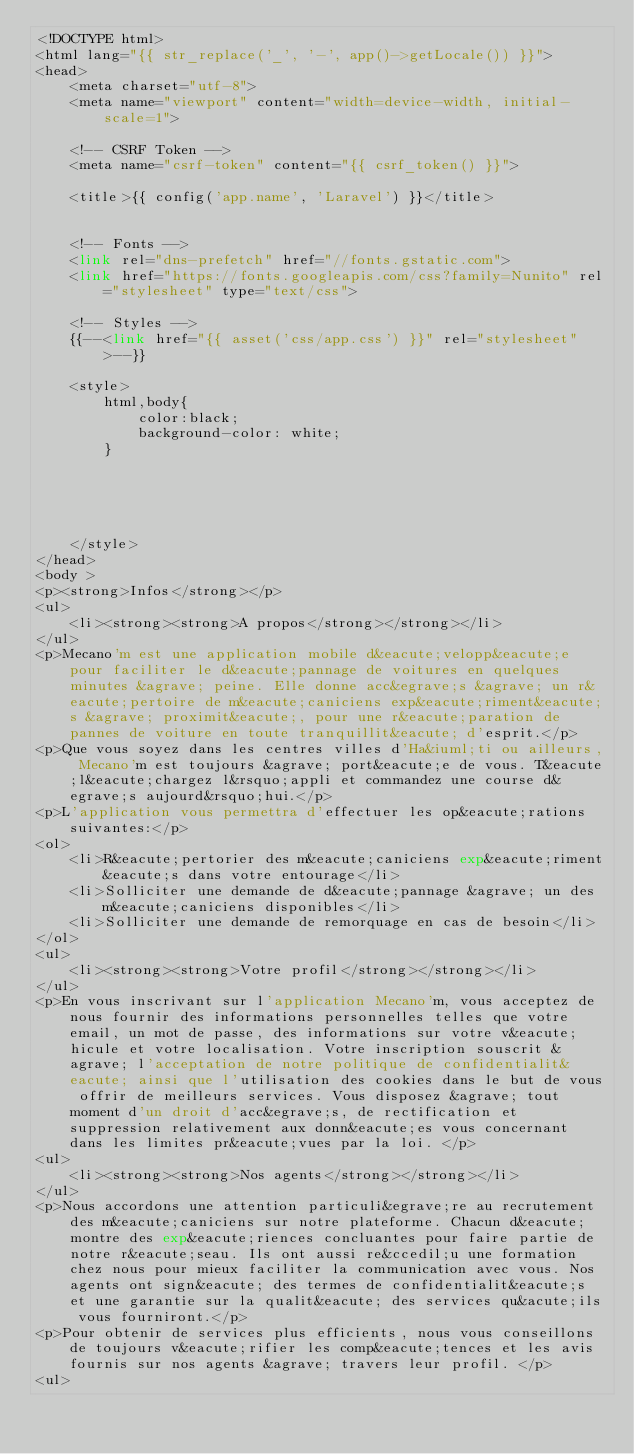Convert code to text. <code><loc_0><loc_0><loc_500><loc_500><_PHP_><!DOCTYPE html>
<html lang="{{ str_replace('_', '-', app()->getLocale()) }}">
<head>
    <meta charset="utf-8">
    <meta name="viewport" content="width=device-width, initial-scale=1">

    <!-- CSRF Token -->
    <meta name="csrf-token" content="{{ csrf_token() }}">

    <title>{{ config('app.name', 'Laravel') }}</title>


    <!-- Fonts -->
    <link rel="dns-prefetch" href="//fonts.gstatic.com">
    <link href="https://fonts.googleapis.com/css?family=Nunito" rel="stylesheet" type="text/css">

    <!-- Styles -->
    {{--<link href="{{ asset('css/app.css') }}" rel="stylesheet">--}}

    <style>
        html,body{
            color:black;
            background-color: white;
        }





    </style>
</head>
<body >
<p><strong>Infos</strong></p>
<ul>
    <li><strong><strong>A propos</strong></strong></li>
</ul>
<p>Mecano'm est une application mobile d&eacute;velopp&eacute;e pour faciliter le d&eacute;pannage de voitures en quelques minutes &agrave; peine. Elle donne acc&egrave;s &agrave; un r&eacute;pertoire de m&eacute;caniciens exp&eacute;riment&eacute;s &agrave; proximit&eacute;, pour une r&eacute;paration de pannes de voiture en toute tranquillit&eacute; d'esprit.</p>
<p>Que vous soyez dans les centres villes d'Ha&iuml;ti ou ailleurs, Mecano'm est toujours &agrave; port&eacute;e de vous. T&eacute;l&eacute;chargez l&rsquo;appli et commandez une course d&egrave;s aujourd&rsquo;hui.</p>
<p>L'application vous permettra d'effectuer les op&eacute;rations suivantes:</p>
<ol>
    <li>R&eacute;pertorier des m&eacute;caniciens exp&eacute;riment&eacute;s dans votre entourage</li>
    <li>Solliciter une demande de d&eacute;pannage &agrave; un des m&eacute;caniciens disponibles</li>
    <li>Solliciter une demande de remorquage en cas de besoin</li>
</ol>
<ul>
    <li><strong><strong>Votre profil</strong></strong></li>
</ul>
<p>En vous inscrivant sur l'application Mecano'm, vous acceptez de nous fournir des informations personnelles telles que votre email, un mot de passe, des informations sur votre v&eacute;hicule et votre localisation. Votre inscription souscrit &agrave; l'acceptation de notre politique de confidentialit&eacute; ainsi que l'utilisation des cookies dans le but de vous offrir de meilleurs services. Vous disposez &agrave; tout moment d'un droit d'acc&egrave;s, de rectification et suppression relativement aux donn&eacute;es vous concernant dans les limites pr&eacute;vues par la loi. </p>
<ul>
    <li><strong><strong>Nos agents</strong></strong></li>
</ul>
<p>Nous accordons une attention particuli&egrave;re au recrutement des m&eacute;caniciens sur notre plateforme. Chacun d&eacute;montre des exp&eacute;riences concluantes pour faire partie de notre r&eacute;seau. Ils ont aussi re&ccedil;u une formation chez nous pour mieux faciliter la communication avec vous. Nos agents ont sign&eacute; des termes de confidentialit&eacute;s et une garantie sur la qualit&eacute; des services qu&acute;ils vous fourniront.</p>
<p>Pour obtenir de services plus efficients, nous vous conseillons de toujours v&eacute;rifier les comp&eacute;tences et les avis fournis sur nos agents &agrave; travers leur profil. </p>
<ul></code> 